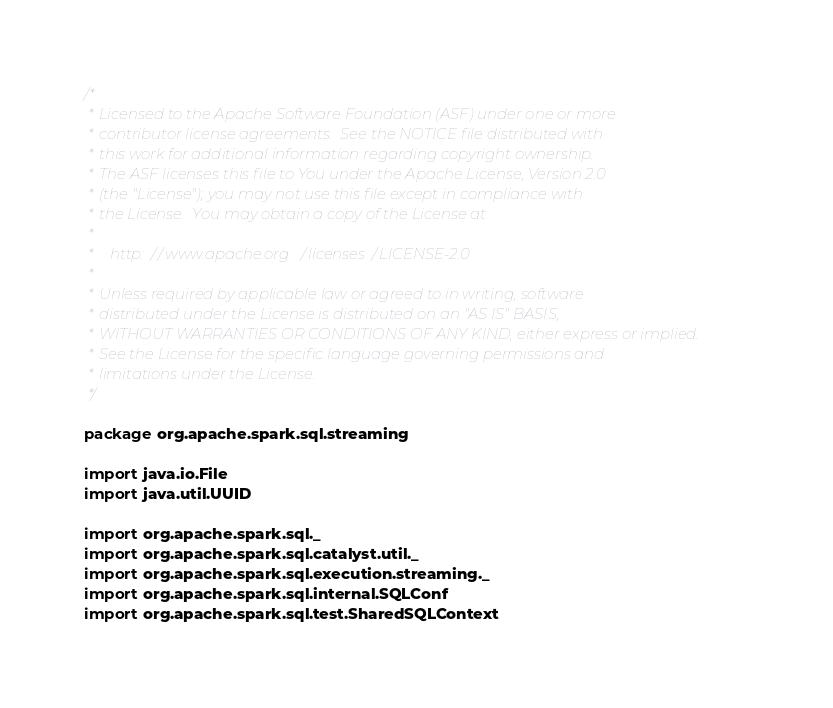<code> <loc_0><loc_0><loc_500><loc_500><_Scala_>/*
 * Licensed to the Apache Software Foundation (ASF) under one or more
 * contributor license agreements.  See the NOTICE file distributed with
 * this work for additional information regarding copyright ownership.
 * The ASF licenses this file to You under the Apache License, Version 2.0
 * (the "License"); you may not use this file except in compliance with
 * the License.  You may obtain a copy of the License at
 *
 *    http://www.apache.org/licenses/LICENSE-2.0
 *
 * Unless required by applicable law or agreed to in writing, software
 * distributed under the License is distributed on an "AS IS" BASIS,
 * WITHOUT WARRANTIES OR CONDITIONS OF ANY KIND, either express or implied.
 * See the License for the specific language governing permissions and
 * limitations under the License.
 */

package org.apache.spark.sql.streaming

import java.io.File
import java.util.UUID

import org.apache.spark.sql._
import org.apache.spark.sql.catalyst.util._
import org.apache.spark.sql.execution.streaming._
import org.apache.spark.sql.internal.SQLConf
import org.apache.spark.sql.test.SharedSQLContext</code> 